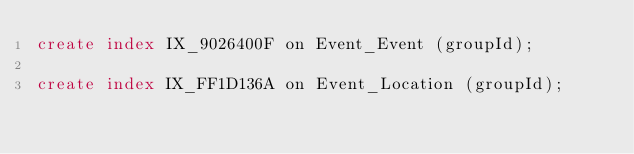Convert code to text. <code><loc_0><loc_0><loc_500><loc_500><_SQL_>create index IX_9026400F on Event_Event (groupId);

create index IX_FF1D136A on Event_Location (groupId);</code> 